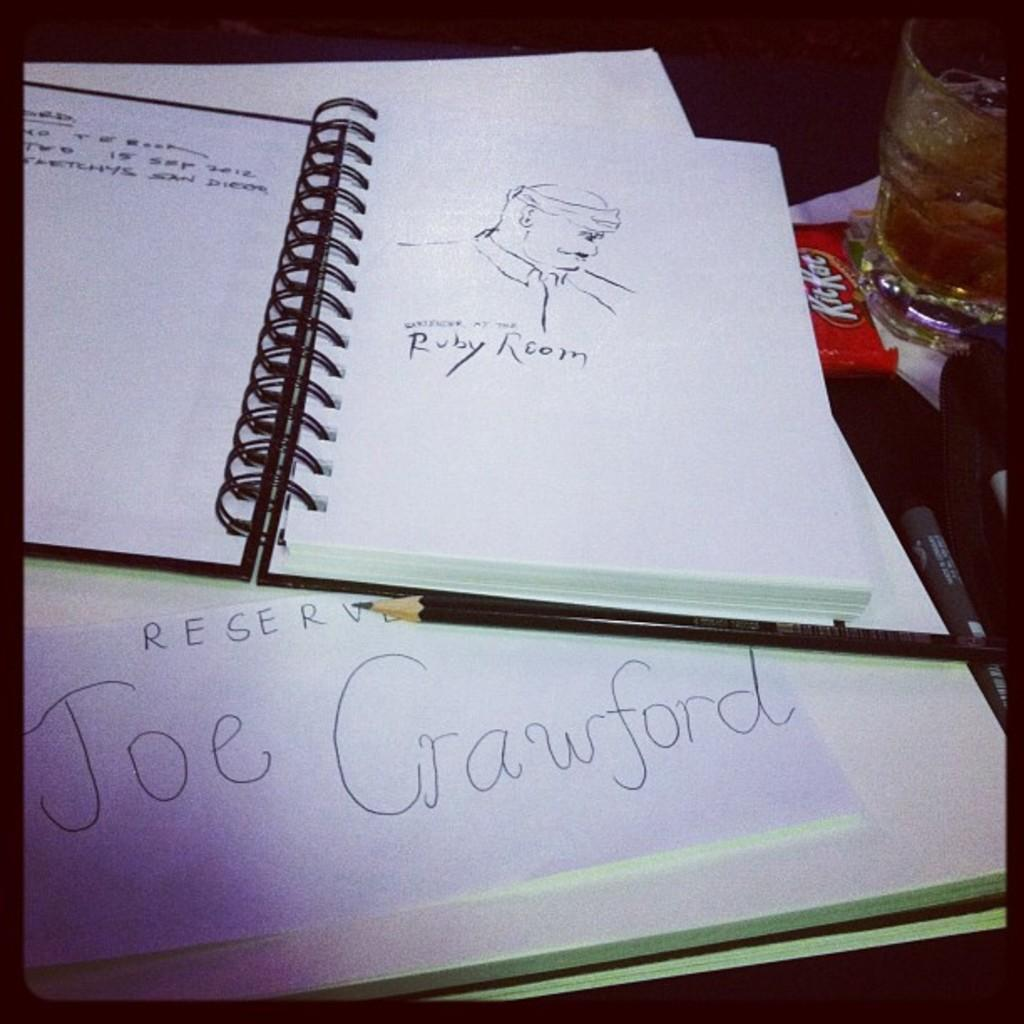<image>
Create a compact narrative representing the image presented. a spiral drawing book with a drawing by joe crawford 